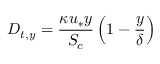<formula> <loc_0><loc_0><loc_500><loc_500>D _ { t , y } = \frac { \kappa u _ { * } y } { S _ { c } } \left ( 1 - \frac { y } { \delta } \right )</formula> 